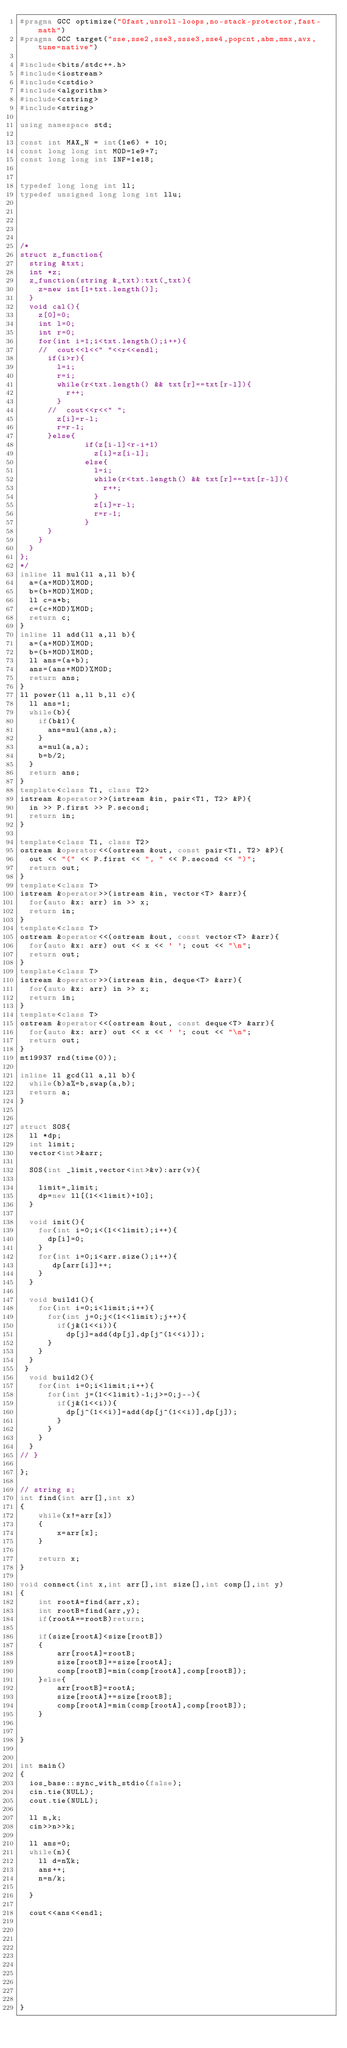<code> <loc_0><loc_0><loc_500><loc_500><_C++_>#pragma GCC optimize("Ofast,unroll-loops,no-stack-protector,fast-math")
#pragma GCC target("sse,sse2,sse3,ssse3,sse4,popcnt,abm,mmx,avx,tune=native")
 
#include<bits/stdc++.h>
#include<iostream>
#include<cstdio>
#include<algorithm>
#include<cstring>
#include<string>
 
using namespace std;
 
const int MAX_N = int(1e6) + 10;
const long long int MOD=1e9+7;
const long long int INF=1e18;
 
 
typedef long long int ll;
typedef unsigned long long int llu;
 
 
 
 
 
/*
struct z_function{
  string &txt;
  int *z;
  z_function(string &_txt):txt(_txt){
    z=new int[1+txt.length()];
  }
  void cal(){
    z[0]=0;
    int l=0;
    int r=0;
    for(int i=1;i<txt.length();i++){
    //  cout<<l<<" "<<r<<endl;
      if(i>r){
        l=i;
        r=i;
        while(r<txt.length() && txt[r]==txt[r-l]){
          r++;
        }
      //  cout<<r<<" ";
        z[i]=r-l;
        r=r-1;
      }else{
              if(z[i-l]<r-i+1)
                z[i]=z[i-l];
              else{
                l=i;
                while(r<txt.length() && txt[r]==txt[r-l]){
                  r++;
                }
                z[i]=r-l;
                r=r-1;
              }
      }
    }
  }
};
*/
inline ll mul(ll a,ll b){
  a=(a+MOD)%MOD;
  b=(b+MOD)%MOD;
  ll c=a*b;
  c=(c+MOD)%MOD;
  return c;
}
inline ll add(ll a,ll b){
  a=(a+MOD)%MOD;
  b=(b+MOD)%MOD;
  ll ans=(a+b);
  ans=(ans+MOD)%MOD;
  return ans;
}
ll power(ll a,ll b,ll c){
  ll ans=1;
  while(b){
    if(b&1){
      ans=mul(ans,a);
    }
    a=mul(a,a);
    b=b/2;
  }
  return ans;
}
template<class T1, class T2>
istream &operator>>(istream &in, pair<T1, T2> &P){
  in >> P.first >> P.second;
  return in;
}
 
template<class T1, class T2>
ostream &operator<<(ostream &out, const pair<T1, T2> &P){
  out << "(" << P.first << ", " << P.second << ")";
  return out;
}
template<class T>
istream &operator>>(istream &in, vector<T> &arr){
  for(auto &x: arr) in >> x;
  return in;
}
template<class T>
ostream &operator<<(ostream &out, const vector<T> &arr){
  for(auto &x: arr) out << x << ' '; cout << "\n";
  return out;
}
template<class T>
istream &operator>>(istream &in, deque<T> &arr){
  for(auto &x: arr) in >> x;
  return in;
}
template<class T>
ostream &operator<<(ostream &out, const deque<T> &arr){
  for(auto &x: arr) out << x << ' '; cout << "\n";
  return out;
}
mt19937 rnd(time(0));
 
inline ll gcd(ll a,ll b){
  while(b)a%=b,swap(a,b);
  return a;
}
 
 
struct SOS{
  ll *dp;
  int limit;
  vector<int>&arr;
 
  SOS(int _limit,vector<int>&v):arr(v){
 
    limit=_limit;
    dp=new ll[(1<<limit)+10];
  }
 
  void init(){
    for(int i=0;i<(1<<limit);i++){
      dp[i]=0;
    }
    for(int i=0;i<arr.size();i++){
       dp[arr[i]]++;
    }
  }
 
  void build1(){
    for(int i=0;i<limit;i++){
      for(int j=0;j<(1<<limit);j++){
        if(j&(1<<i)){
          dp[j]=add(dp[j],dp[j^(1<<i)]);
      }
    }
  }
 }
  void build2(){
    for(int i=0;i<limit;i++){
      for(int j=(1<<limit)-1;j>=0;j--){
        if(j&(1<<i)){
          dp[j^(1<<i)]=add(dp[j^(1<<i)],dp[j]);
        }
      }
    }
  }
// }
 
};
 
// string s;
int find(int arr[],int x)
{
    while(x!=arr[x])
    {
        x=arr[x];
    }
 
    return x;
}
 
void connect(int x,int arr[],int size[],int comp[],int y)
{
    int rootA=find(arr,x);
    int rootB=find(arr,y);
    if(rootA==rootB)return;
 
    if(size[rootA]<size[rootB])
    {
        arr[rootA]=rootB;
        size[rootB]+=size[rootA];
        comp[rootB]=min(comp[rootA],comp[rootB]);
    }else{
        arr[rootB]=rootA;
        size[rootA]+=size[rootB];
        comp[rootA]=min(comp[rootA],comp[rootB]);
    }
 
 
}
 
 
int main()
{
  ios_base::sync_with_stdio(false);
  cin.tie(NULL);
  cout.tie(NULL);

  ll n,k;
  cin>>n>>k;

  ll ans=0;
  while(n){
    ll d=n%k;
    ans++;
    n=n/k;

  }

  cout<<ans<<endl;
 
  
 
  
 
 
  
 
  
 
}
</code> 